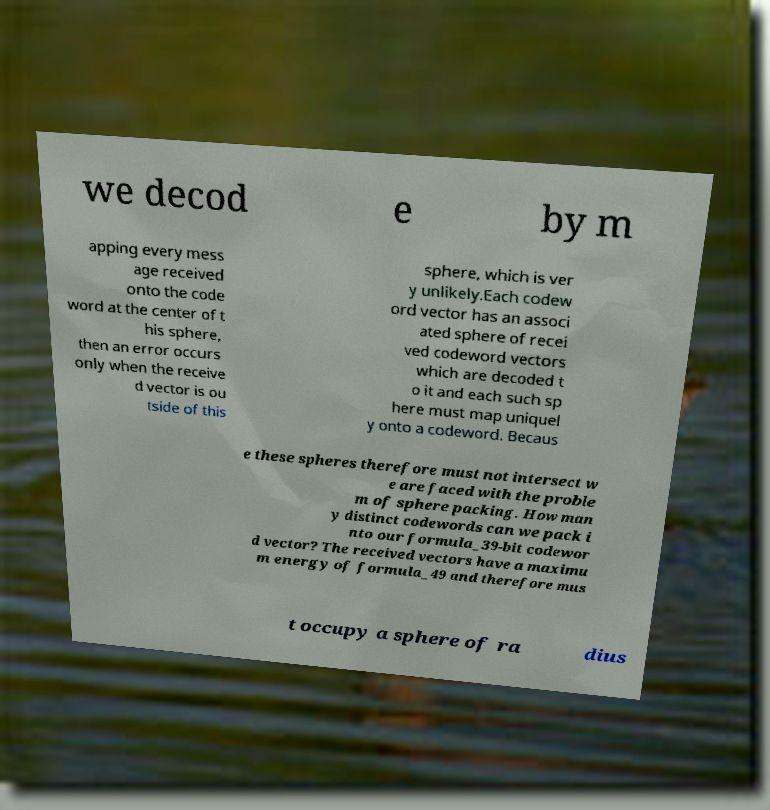What messages or text are displayed in this image? I need them in a readable, typed format. we decod e by m apping every mess age received onto the code word at the center of t his sphere, then an error occurs only when the receive d vector is ou tside of this sphere, which is ver y unlikely.Each codew ord vector has an associ ated sphere of recei ved codeword vectors which are decoded t o it and each such sp here must map uniquel y onto a codeword. Becaus e these spheres therefore must not intersect w e are faced with the proble m of sphere packing. How man y distinct codewords can we pack i nto our formula_39-bit codewor d vector? The received vectors have a maximu m energy of formula_49 and therefore mus t occupy a sphere of ra dius 